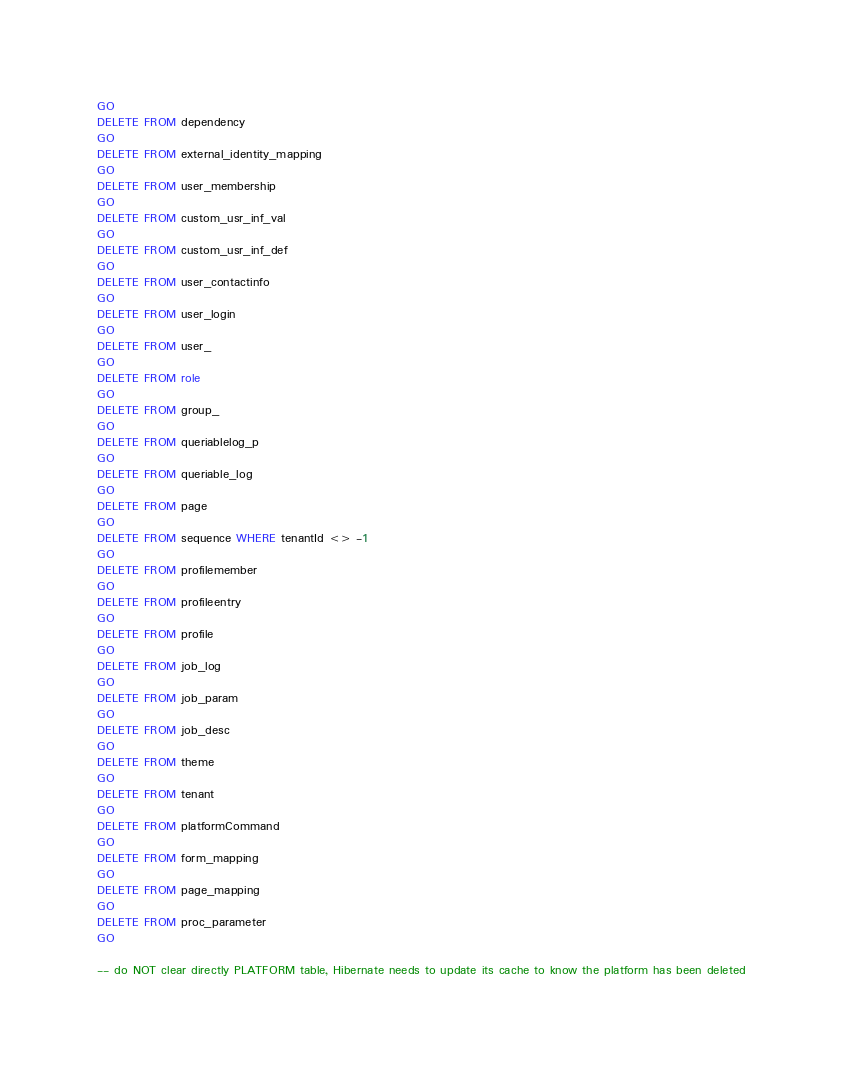<code> <loc_0><loc_0><loc_500><loc_500><_SQL_>GO
DELETE FROM dependency
GO
DELETE FROM external_identity_mapping
GO
DELETE FROM user_membership
GO
DELETE FROM custom_usr_inf_val
GO
DELETE FROM custom_usr_inf_def
GO
DELETE FROM user_contactinfo
GO
DELETE FROM user_login
GO
DELETE FROM user_
GO
DELETE FROM role
GO
DELETE FROM group_
GO
DELETE FROM queriablelog_p
GO
DELETE FROM queriable_log
GO
DELETE FROM page
GO
DELETE FROM sequence WHERE tenantId <> -1
GO
DELETE FROM profilemember
GO
DELETE FROM profileentry
GO
DELETE FROM profile
GO
DELETE FROM job_log
GO
DELETE FROM job_param
GO
DELETE FROM job_desc
GO
DELETE FROM theme
GO
DELETE FROM tenant
GO
DELETE FROM platformCommand
GO
DELETE FROM form_mapping
GO
DELETE FROM page_mapping
GO
DELETE FROM proc_parameter
GO

-- do NOT clear directly PLATFORM table, Hibernate needs to update its cache to know the platform has been deleted</code> 